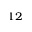Convert formula to latex. <formula><loc_0><loc_0><loc_500><loc_500>^ { 1 2 }</formula> 